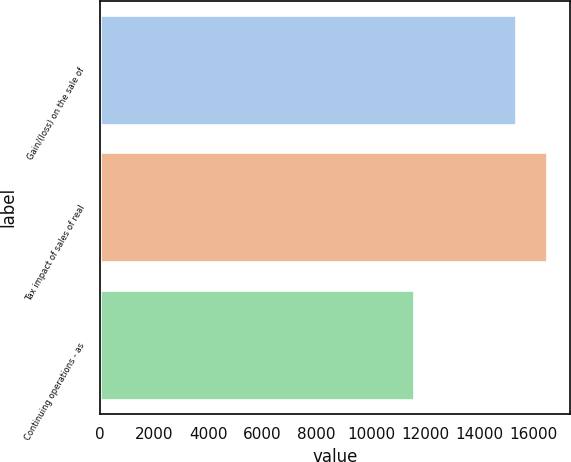<chart> <loc_0><loc_0><loc_500><loc_500><bar_chart><fcel>Gain/(loss) on the sale of<fcel>Tax impact of sales of real<fcel>Continuing operations - as<nl><fcel>15348<fcel>16505.4<fcel>11574<nl></chart> 